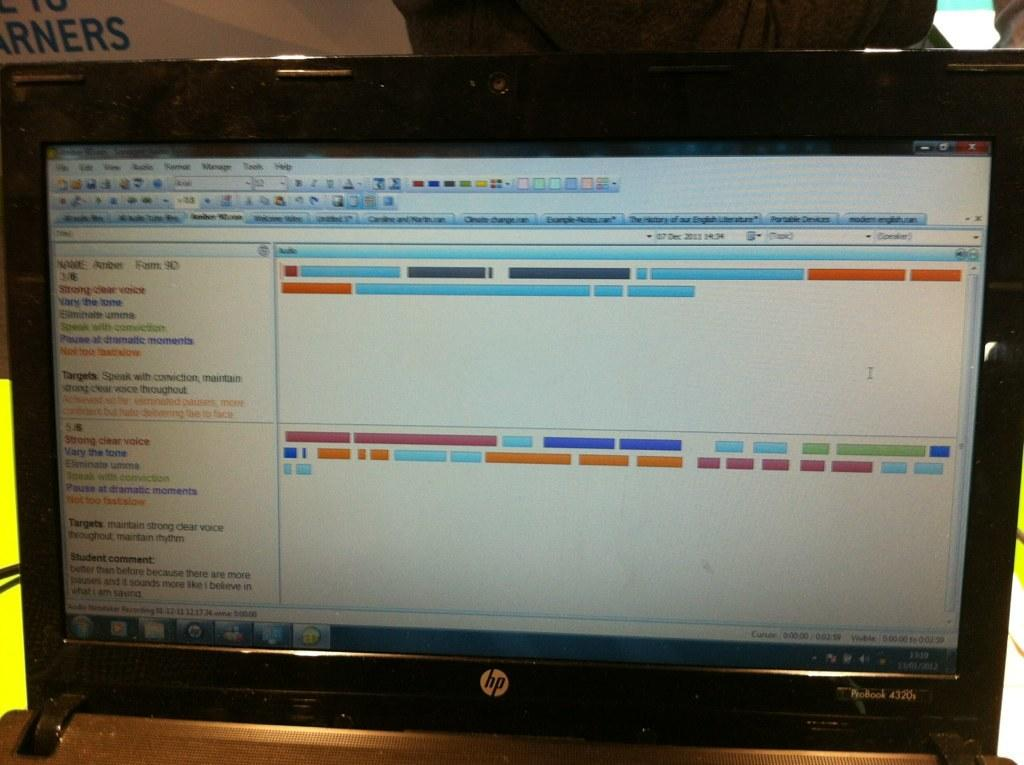<image>
Relay a brief, clear account of the picture shown. HP computer monitor showing the name Amber on it. 